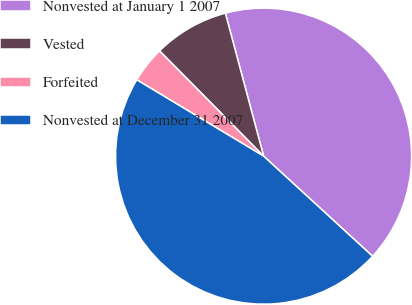Convert chart. <chart><loc_0><loc_0><loc_500><loc_500><pie_chart><fcel>Nonvested at January 1 2007<fcel>Vested<fcel>Forfeited<fcel>Nonvested at December 31 2007<nl><fcel>40.99%<fcel>8.25%<fcel>3.97%<fcel>46.8%<nl></chart> 